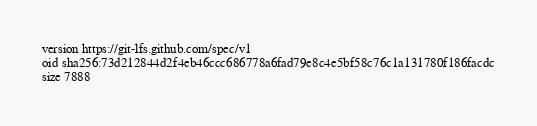Convert code to text. <code><loc_0><loc_0><loc_500><loc_500><_YAML_>version https://git-lfs.github.com/spec/v1
oid sha256:73d212844d2f4eb46ccc686778a6fad79e8c4e5bf58c76c1a131780f186facdc
size 7888
</code> 